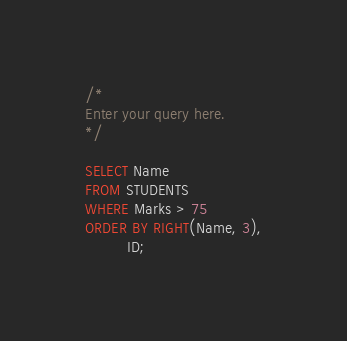Convert code to text. <code><loc_0><loc_0><loc_500><loc_500><_SQL_>/*
Enter your query here.
*/

SELECT Name
FROM STUDENTS
WHERE Marks > 75
ORDER BY RIGHT(Name, 3),
         ID;</code> 